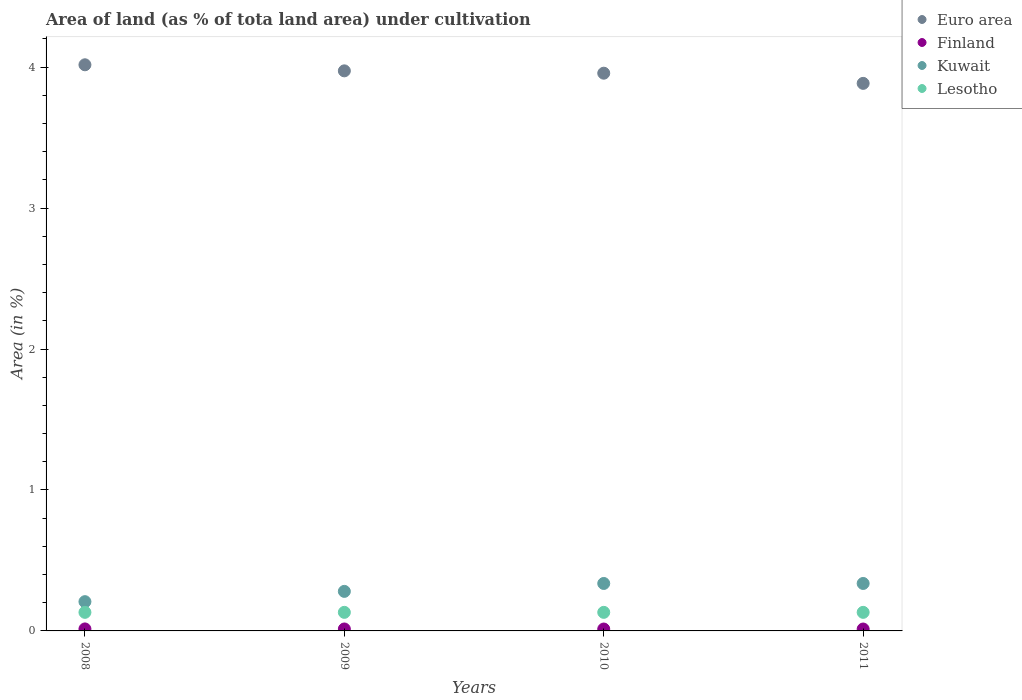How many different coloured dotlines are there?
Your response must be concise. 4. Is the number of dotlines equal to the number of legend labels?
Your answer should be very brief. Yes. What is the percentage of land under cultivation in Lesotho in 2010?
Give a very brief answer. 0.13. Across all years, what is the maximum percentage of land under cultivation in Kuwait?
Make the answer very short. 0.34. Across all years, what is the minimum percentage of land under cultivation in Finland?
Provide a succinct answer. 0.01. In which year was the percentage of land under cultivation in Euro area minimum?
Ensure brevity in your answer.  2011. What is the total percentage of land under cultivation in Lesotho in the graph?
Your response must be concise. 0.53. What is the difference between the percentage of land under cultivation in Kuwait in 2008 and that in 2010?
Keep it short and to the point. -0.13. What is the difference between the percentage of land under cultivation in Euro area in 2009 and the percentage of land under cultivation in Finland in 2010?
Offer a very short reply. 3.96. What is the average percentage of land under cultivation in Euro area per year?
Your answer should be compact. 3.96. In the year 2009, what is the difference between the percentage of land under cultivation in Finland and percentage of land under cultivation in Kuwait?
Offer a terse response. -0.27. In how many years, is the percentage of land under cultivation in Euro area greater than 0.8 %?
Ensure brevity in your answer.  4. Is the percentage of land under cultivation in Euro area in 2010 less than that in 2011?
Give a very brief answer. No. Is the difference between the percentage of land under cultivation in Finland in 2009 and 2010 greater than the difference between the percentage of land under cultivation in Kuwait in 2009 and 2010?
Your answer should be very brief. Yes. What is the difference between the highest and the second highest percentage of land under cultivation in Lesotho?
Give a very brief answer. 0. What is the difference between the highest and the lowest percentage of land under cultivation in Kuwait?
Offer a terse response. 0.13. Is it the case that in every year, the sum of the percentage of land under cultivation in Kuwait and percentage of land under cultivation in Lesotho  is greater than the sum of percentage of land under cultivation in Euro area and percentage of land under cultivation in Finland?
Your answer should be compact. No. Is it the case that in every year, the sum of the percentage of land under cultivation in Kuwait and percentage of land under cultivation in Lesotho  is greater than the percentage of land under cultivation in Euro area?
Provide a short and direct response. No. Does the percentage of land under cultivation in Kuwait monotonically increase over the years?
Your response must be concise. No. Is the percentage of land under cultivation in Euro area strictly greater than the percentage of land under cultivation in Lesotho over the years?
Provide a succinct answer. Yes. Is the percentage of land under cultivation in Finland strictly less than the percentage of land under cultivation in Euro area over the years?
Offer a terse response. Yes. How many years are there in the graph?
Give a very brief answer. 4. What is the difference between two consecutive major ticks on the Y-axis?
Provide a succinct answer. 1. Does the graph contain any zero values?
Your answer should be compact. No. Does the graph contain grids?
Give a very brief answer. No. Where does the legend appear in the graph?
Your answer should be compact. Top right. What is the title of the graph?
Provide a short and direct response. Area of land (as % of tota land area) under cultivation. Does "Trinidad and Tobago" appear as one of the legend labels in the graph?
Ensure brevity in your answer.  No. What is the label or title of the X-axis?
Give a very brief answer. Years. What is the label or title of the Y-axis?
Give a very brief answer. Area (in %). What is the Area (in %) in Euro area in 2008?
Make the answer very short. 4.02. What is the Area (in %) in Finland in 2008?
Keep it short and to the point. 0.01. What is the Area (in %) in Kuwait in 2008?
Provide a short and direct response. 0.21. What is the Area (in %) of Lesotho in 2008?
Give a very brief answer. 0.13. What is the Area (in %) of Euro area in 2009?
Your response must be concise. 3.97. What is the Area (in %) of Finland in 2009?
Offer a very short reply. 0.01. What is the Area (in %) in Kuwait in 2009?
Your answer should be very brief. 0.28. What is the Area (in %) in Lesotho in 2009?
Keep it short and to the point. 0.13. What is the Area (in %) in Euro area in 2010?
Your response must be concise. 3.96. What is the Area (in %) in Finland in 2010?
Provide a succinct answer. 0.01. What is the Area (in %) of Kuwait in 2010?
Offer a terse response. 0.34. What is the Area (in %) in Lesotho in 2010?
Your answer should be very brief. 0.13. What is the Area (in %) of Euro area in 2011?
Offer a terse response. 3.88. What is the Area (in %) in Finland in 2011?
Ensure brevity in your answer.  0.01. What is the Area (in %) in Kuwait in 2011?
Make the answer very short. 0.34. What is the Area (in %) of Lesotho in 2011?
Your response must be concise. 0.13. Across all years, what is the maximum Area (in %) of Euro area?
Provide a short and direct response. 4.02. Across all years, what is the maximum Area (in %) of Finland?
Make the answer very short. 0.01. Across all years, what is the maximum Area (in %) of Kuwait?
Your response must be concise. 0.34. Across all years, what is the maximum Area (in %) in Lesotho?
Give a very brief answer. 0.13. Across all years, what is the minimum Area (in %) of Euro area?
Provide a short and direct response. 3.88. Across all years, what is the minimum Area (in %) of Finland?
Ensure brevity in your answer.  0.01. Across all years, what is the minimum Area (in %) in Kuwait?
Provide a short and direct response. 0.21. Across all years, what is the minimum Area (in %) in Lesotho?
Make the answer very short. 0.13. What is the total Area (in %) in Euro area in the graph?
Provide a short and direct response. 15.83. What is the total Area (in %) in Finland in the graph?
Keep it short and to the point. 0.06. What is the total Area (in %) of Kuwait in the graph?
Keep it short and to the point. 1.16. What is the total Area (in %) in Lesotho in the graph?
Offer a very short reply. 0.53. What is the difference between the Area (in %) in Euro area in 2008 and that in 2009?
Your answer should be compact. 0.04. What is the difference between the Area (in %) of Kuwait in 2008 and that in 2009?
Ensure brevity in your answer.  -0.07. What is the difference between the Area (in %) in Euro area in 2008 and that in 2010?
Offer a very short reply. 0.06. What is the difference between the Area (in %) of Finland in 2008 and that in 2010?
Offer a very short reply. 0. What is the difference between the Area (in %) of Kuwait in 2008 and that in 2010?
Offer a terse response. -0.13. What is the difference between the Area (in %) in Lesotho in 2008 and that in 2010?
Your answer should be very brief. 0. What is the difference between the Area (in %) in Euro area in 2008 and that in 2011?
Provide a succinct answer. 0.13. What is the difference between the Area (in %) in Finland in 2008 and that in 2011?
Ensure brevity in your answer.  0. What is the difference between the Area (in %) of Kuwait in 2008 and that in 2011?
Your response must be concise. -0.13. What is the difference between the Area (in %) in Lesotho in 2008 and that in 2011?
Ensure brevity in your answer.  0. What is the difference between the Area (in %) in Euro area in 2009 and that in 2010?
Offer a terse response. 0.02. What is the difference between the Area (in %) of Kuwait in 2009 and that in 2010?
Provide a succinct answer. -0.06. What is the difference between the Area (in %) of Euro area in 2009 and that in 2011?
Make the answer very short. 0.09. What is the difference between the Area (in %) of Kuwait in 2009 and that in 2011?
Provide a short and direct response. -0.06. What is the difference between the Area (in %) in Lesotho in 2009 and that in 2011?
Provide a succinct answer. 0. What is the difference between the Area (in %) of Euro area in 2010 and that in 2011?
Make the answer very short. 0.07. What is the difference between the Area (in %) in Euro area in 2008 and the Area (in %) in Finland in 2009?
Keep it short and to the point. 4. What is the difference between the Area (in %) of Euro area in 2008 and the Area (in %) of Kuwait in 2009?
Your response must be concise. 3.74. What is the difference between the Area (in %) of Euro area in 2008 and the Area (in %) of Lesotho in 2009?
Provide a succinct answer. 3.89. What is the difference between the Area (in %) in Finland in 2008 and the Area (in %) in Kuwait in 2009?
Give a very brief answer. -0.27. What is the difference between the Area (in %) in Finland in 2008 and the Area (in %) in Lesotho in 2009?
Your response must be concise. -0.12. What is the difference between the Area (in %) in Kuwait in 2008 and the Area (in %) in Lesotho in 2009?
Make the answer very short. 0.08. What is the difference between the Area (in %) in Euro area in 2008 and the Area (in %) in Finland in 2010?
Make the answer very short. 4. What is the difference between the Area (in %) of Euro area in 2008 and the Area (in %) of Kuwait in 2010?
Keep it short and to the point. 3.68. What is the difference between the Area (in %) of Euro area in 2008 and the Area (in %) of Lesotho in 2010?
Provide a short and direct response. 3.89. What is the difference between the Area (in %) of Finland in 2008 and the Area (in %) of Kuwait in 2010?
Ensure brevity in your answer.  -0.32. What is the difference between the Area (in %) in Finland in 2008 and the Area (in %) in Lesotho in 2010?
Offer a terse response. -0.12. What is the difference between the Area (in %) in Kuwait in 2008 and the Area (in %) in Lesotho in 2010?
Provide a short and direct response. 0.08. What is the difference between the Area (in %) of Euro area in 2008 and the Area (in %) of Finland in 2011?
Your response must be concise. 4. What is the difference between the Area (in %) of Euro area in 2008 and the Area (in %) of Kuwait in 2011?
Your answer should be compact. 3.68. What is the difference between the Area (in %) of Euro area in 2008 and the Area (in %) of Lesotho in 2011?
Your answer should be compact. 3.89. What is the difference between the Area (in %) in Finland in 2008 and the Area (in %) in Kuwait in 2011?
Your response must be concise. -0.32. What is the difference between the Area (in %) of Finland in 2008 and the Area (in %) of Lesotho in 2011?
Give a very brief answer. -0.12. What is the difference between the Area (in %) in Kuwait in 2008 and the Area (in %) in Lesotho in 2011?
Provide a succinct answer. 0.08. What is the difference between the Area (in %) in Euro area in 2009 and the Area (in %) in Finland in 2010?
Offer a very short reply. 3.96. What is the difference between the Area (in %) in Euro area in 2009 and the Area (in %) in Kuwait in 2010?
Keep it short and to the point. 3.64. What is the difference between the Area (in %) in Euro area in 2009 and the Area (in %) in Lesotho in 2010?
Offer a very short reply. 3.84. What is the difference between the Area (in %) in Finland in 2009 and the Area (in %) in Kuwait in 2010?
Ensure brevity in your answer.  -0.32. What is the difference between the Area (in %) of Finland in 2009 and the Area (in %) of Lesotho in 2010?
Keep it short and to the point. -0.12. What is the difference between the Area (in %) of Kuwait in 2009 and the Area (in %) of Lesotho in 2010?
Your answer should be very brief. 0.15. What is the difference between the Area (in %) in Euro area in 2009 and the Area (in %) in Finland in 2011?
Make the answer very short. 3.96. What is the difference between the Area (in %) in Euro area in 2009 and the Area (in %) in Kuwait in 2011?
Make the answer very short. 3.64. What is the difference between the Area (in %) in Euro area in 2009 and the Area (in %) in Lesotho in 2011?
Give a very brief answer. 3.84. What is the difference between the Area (in %) in Finland in 2009 and the Area (in %) in Kuwait in 2011?
Your response must be concise. -0.32. What is the difference between the Area (in %) of Finland in 2009 and the Area (in %) of Lesotho in 2011?
Provide a succinct answer. -0.12. What is the difference between the Area (in %) in Kuwait in 2009 and the Area (in %) in Lesotho in 2011?
Ensure brevity in your answer.  0.15. What is the difference between the Area (in %) in Euro area in 2010 and the Area (in %) in Finland in 2011?
Provide a short and direct response. 3.94. What is the difference between the Area (in %) in Euro area in 2010 and the Area (in %) in Kuwait in 2011?
Give a very brief answer. 3.62. What is the difference between the Area (in %) of Euro area in 2010 and the Area (in %) of Lesotho in 2011?
Make the answer very short. 3.83. What is the difference between the Area (in %) in Finland in 2010 and the Area (in %) in Kuwait in 2011?
Give a very brief answer. -0.32. What is the difference between the Area (in %) of Finland in 2010 and the Area (in %) of Lesotho in 2011?
Your answer should be very brief. -0.12. What is the difference between the Area (in %) of Kuwait in 2010 and the Area (in %) of Lesotho in 2011?
Provide a short and direct response. 0.2. What is the average Area (in %) of Euro area per year?
Offer a very short reply. 3.96. What is the average Area (in %) of Finland per year?
Provide a short and direct response. 0.01. What is the average Area (in %) of Kuwait per year?
Provide a succinct answer. 0.29. What is the average Area (in %) in Lesotho per year?
Provide a short and direct response. 0.13. In the year 2008, what is the difference between the Area (in %) in Euro area and Area (in %) in Finland?
Offer a very short reply. 4. In the year 2008, what is the difference between the Area (in %) in Euro area and Area (in %) in Kuwait?
Offer a very short reply. 3.81. In the year 2008, what is the difference between the Area (in %) of Euro area and Area (in %) of Lesotho?
Your answer should be compact. 3.89. In the year 2008, what is the difference between the Area (in %) in Finland and Area (in %) in Kuwait?
Give a very brief answer. -0.19. In the year 2008, what is the difference between the Area (in %) in Finland and Area (in %) in Lesotho?
Your response must be concise. -0.12. In the year 2008, what is the difference between the Area (in %) of Kuwait and Area (in %) of Lesotho?
Your answer should be compact. 0.08. In the year 2009, what is the difference between the Area (in %) in Euro area and Area (in %) in Finland?
Your answer should be compact. 3.96. In the year 2009, what is the difference between the Area (in %) in Euro area and Area (in %) in Kuwait?
Give a very brief answer. 3.69. In the year 2009, what is the difference between the Area (in %) of Euro area and Area (in %) of Lesotho?
Provide a succinct answer. 3.84. In the year 2009, what is the difference between the Area (in %) of Finland and Area (in %) of Kuwait?
Keep it short and to the point. -0.27. In the year 2009, what is the difference between the Area (in %) in Finland and Area (in %) in Lesotho?
Provide a short and direct response. -0.12. In the year 2009, what is the difference between the Area (in %) of Kuwait and Area (in %) of Lesotho?
Make the answer very short. 0.15. In the year 2010, what is the difference between the Area (in %) of Euro area and Area (in %) of Finland?
Offer a very short reply. 3.94. In the year 2010, what is the difference between the Area (in %) in Euro area and Area (in %) in Kuwait?
Provide a short and direct response. 3.62. In the year 2010, what is the difference between the Area (in %) of Euro area and Area (in %) of Lesotho?
Offer a terse response. 3.83. In the year 2010, what is the difference between the Area (in %) of Finland and Area (in %) of Kuwait?
Make the answer very short. -0.32. In the year 2010, what is the difference between the Area (in %) of Finland and Area (in %) of Lesotho?
Offer a terse response. -0.12. In the year 2010, what is the difference between the Area (in %) in Kuwait and Area (in %) in Lesotho?
Provide a short and direct response. 0.2. In the year 2011, what is the difference between the Area (in %) of Euro area and Area (in %) of Finland?
Offer a very short reply. 3.87. In the year 2011, what is the difference between the Area (in %) of Euro area and Area (in %) of Kuwait?
Give a very brief answer. 3.55. In the year 2011, what is the difference between the Area (in %) of Euro area and Area (in %) of Lesotho?
Your response must be concise. 3.75. In the year 2011, what is the difference between the Area (in %) of Finland and Area (in %) of Kuwait?
Offer a terse response. -0.32. In the year 2011, what is the difference between the Area (in %) in Finland and Area (in %) in Lesotho?
Your response must be concise. -0.12. In the year 2011, what is the difference between the Area (in %) of Kuwait and Area (in %) of Lesotho?
Provide a succinct answer. 0.2. What is the ratio of the Area (in %) of Euro area in 2008 to that in 2009?
Offer a terse response. 1.01. What is the ratio of the Area (in %) in Finland in 2008 to that in 2009?
Make the answer very short. 1.02. What is the ratio of the Area (in %) of Kuwait in 2008 to that in 2009?
Offer a terse response. 0.74. What is the ratio of the Area (in %) in Euro area in 2008 to that in 2010?
Make the answer very short. 1.02. What is the ratio of the Area (in %) of Finland in 2008 to that in 2010?
Ensure brevity in your answer.  1.05. What is the ratio of the Area (in %) of Kuwait in 2008 to that in 2010?
Your response must be concise. 0.62. What is the ratio of the Area (in %) in Lesotho in 2008 to that in 2010?
Offer a terse response. 1. What is the ratio of the Area (in %) of Euro area in 2008 to that in 2011?
Offer a very short reply. 1.03. What is the ratio of the Area (in %) of Finland in 2008 to that in 2011?
Offer a very short reply. 1.05. What is the ratio of the Area (in %) of Kuwait in 2008 to that in 2011?
Offer a terse response. 0.62. What is the ratio of the Area (in %) of Finland in 2009 to that in 2010?
Your answer should be very brief. 1.02. What is the ratio of the Area (in %) of Lesotho in 2009 to that in 2010?
Make the answer very short. 1. What is the ratio of the Area (in %) of Euro area in 2009 to that in 2011?
Keep it short and to the point. 1.02. What is the ratio of the Area (in %) of Finland in 2009 to that in 2011?
Offer a terse response. 1.02. What is the ratio of the Area (in %) in Euro area in 2010 to that in 2011?
Offer a terse response. 1.02. What is the ratio of the Area (in %) in Finland in 2010 to that in 2011?
Offer a terse response. 1. What is the ratio of the Area (in %) in Kuwait in 2010 to that in 2011?
Provide a succinct answer. 1. What is the ratio of the Area (in %) in Lesotho in 2010 to that in 2011?
Offer a very short reply. 1. What is the difference between the highest and the second highest Area (in %) in Euro area?
Your response must be concise. 0.04. What is the difference between the highest and the second highest Area (in %) of Finland?
Your answer should be compact. 0. What is the difference between the highest and the second highest Area (in %) of Kuwait?
Offer a terse response. 0. What is the difference between the highest and the second highest Area (in %) of Lesotho?
Your response must be concise. 0. What is the difference between the highest and the lowest Area (in %) in Euro area?
Offer a very short reply. 0.13. What is the difference between the highest and the lowest Area (in %) in Finland?
Provide a succinct answer. 0. What is the difference between the highest and the lowest Area (in %) of Kuwait?
Offer a very short reply. 0.13. 